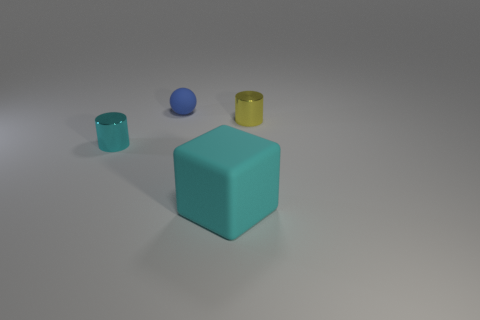What number of things are either big blue rubber spheres or matte balls?
Give a very brief answer. 1. What size is the cyan thing right of the tiny cyan object?
Provide a succinct answer. Large. How many matte balls are right of the cylinder to the right of the cylinder that is to the left of the large cyan object?
Provide a short and direct response. 0. Do the matte sphere and the big cube have the same color?
Provide a short and direct response. No. What number of objects are both to the right of the tiny cyan shiny cylinder and behind the big cyan object?
Ensure brevity in your answer.  2. There is a cyan thing behind the large cyan matte object; what is its shape?
Provide a short and direct response. Cylinder. Is the number of cyan matte objects on the right side of the blue rubber object less than the number of small things that are on the right side of the large rubber object?
Offer a terse response. No. Is the material of the cylinder on the left side of the ball the same as the tiny thing behind the yellow object?
Offer a very short reply. No. The cyan rubber object has what shape?
Provide a succinct answer. Cube. Are there more spheres behind the tiny cyan thing than large cyan matte cubes that are behind the large cyan matte cube?
Ensure brevity in your answer.  Yes. 